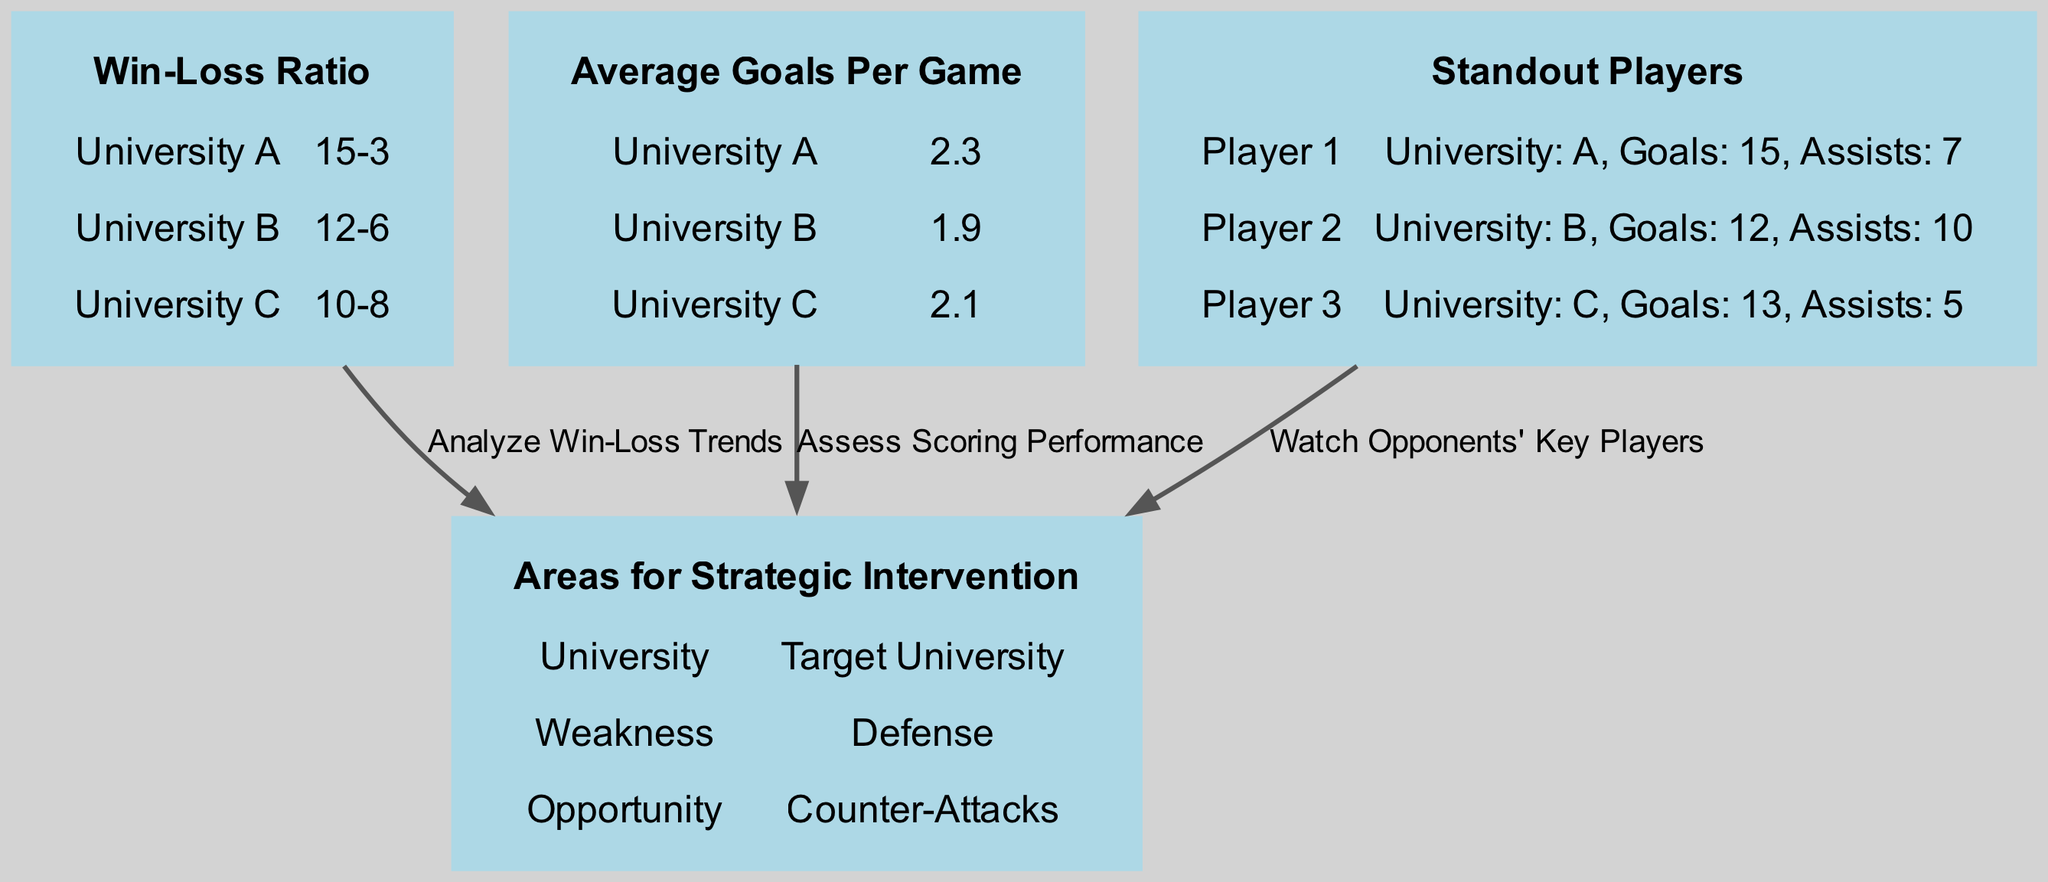What is the Win-Loss Ratio of University A? The diagram lists the win-loss ratio for each university under the "Win-Loss Ratio" node. From the information given, University A's ratio is shown as "15-3".
Answer: 15-3 Which university has the highest average goals per game? The "Average Goals Per Game" node presents the average goals for each university. University A has an average of 2.3 goals per game, which is greater than the others (1.9 for University B and 2.1 for University C).
Answer: University A What is the weakness identified for the target university? The "Areas for Strategic Intervention" node mentions the weakness of the target university is "Defense". This is explicitly stated in the data under that node.
Answer: Defense How many standout players are listed in the diagram? The "Standout Players" node contains a list of three different players. Each player is represented as a unique entry in this section. Thus, counting these yields a total of three standout players.
Answer: 3 Which player has the most goals? By examining the "Standout Players" node, Player 1 from University A has 15 goals, which is indicated as the highest compared to other players (12 for Player 2 and 13 for Player 3).
Answer: Player 1 What relationship connects "Win-Loss Ratio" to "Areas for Strategic Intervention"? The diagram depicts a directed edge labeled "Analyze Win-Loss Trends" from the "Win-Loss Ratio" node pointing to "Areas for Strategic Intervention", indicating that information from win-loss trends influences strategic decisions.
Answer: Analyze Win-Loss Trends What opportunity is highlighted for the target university? The "Areas for Strategic Intervention" node directly lists the opportunity for the target university as "Counter-Attacks", which signifies a tactical area to exploit.
Answer: Counter-Attacks What is the average goals per game for University C? Within the "Average Goals Per Game" node, University C's average is noted as 2.1, which indicates the number of goals they score on average in a game.
Answer: 2.1 